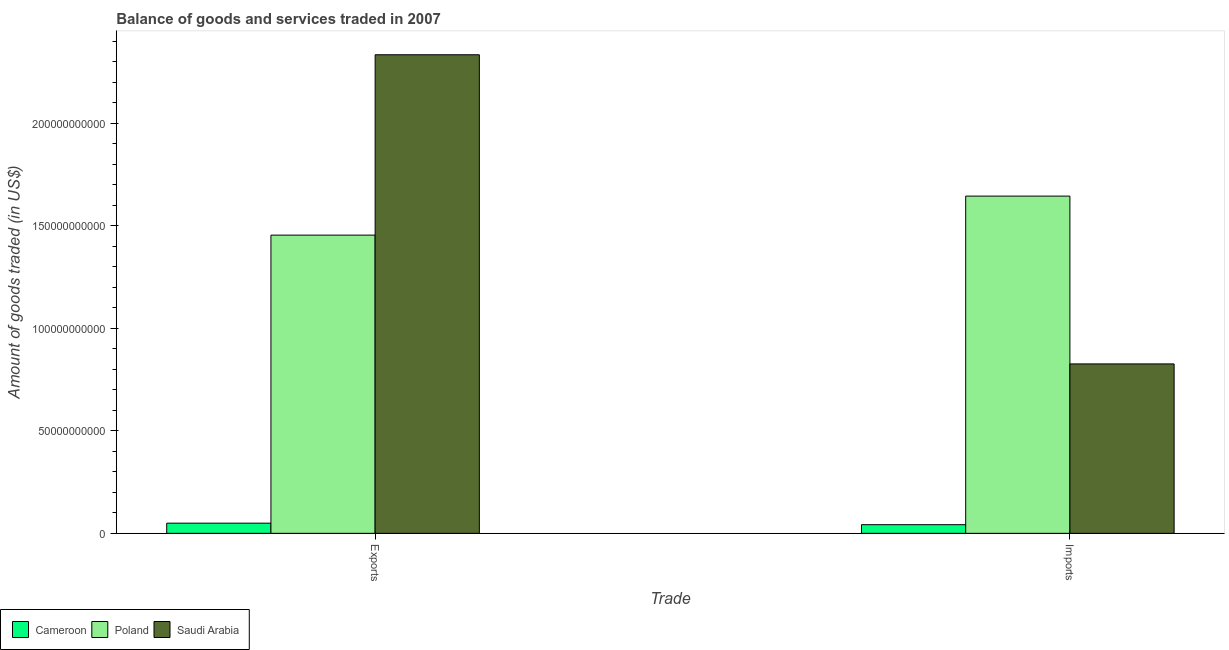How many different coloured bars are there?
Your response must be concise. 3. How many groups of bars are there?
Offer a very short reply. 2. Are the number of bars per tick equal to the number of legend labels?
Provide a short and direct response. Yes. How many bars are there on the 2nd tick from the left?
Give a very brief answer. 3. How many bars are there on the 2nd tick from the right?
Keep it short and to the point. 3. What is the label of the 1st group of bars from the left?
Provide a succinct answer. Exports. What is the amount of goods exported in Cameroon?
Make the answer very short. 4.96e+09. Across all countries, what is the maximum amount of goods imported?
Provide a short and direct response. 1.64e+11. Across all countries, what is the minimum amount of goods exported?
Keep it short and to the point. 4.96e+09. In which country was the amount of goods imported minimum?
Keep it short and to the point. Cameroon. What is the total amount of goods exported in the graph?
Offer a terse response. 3.84e+11. What is the difference between the amount of goods imported in Saudi Arabia and that in Poland?
Your response must be concise. -8.18e+1. What is the difference between the amount of goods exported in Poland and the amount of goods imported in Cameroon?
Make the answer very short. 1.41e+11. What is the average amount of goods imported per country?
Provide a succinct answer. 8.37e+1. What is the difference between the amount of goods imported and amount of goods exported in Poland?
Provide a succinct answer. 1.90e+1. In how many countries, is the amount of goods imported greater than 190000000000 US$?
Your answer should be compact. 0. What is the ratio of the amount of goods exported in Saudi Arabia to that in Cameroon?
Keep it short and to the point. 47.08. What does the 3rd bar from the left in Imports represents?
Keep it short and to the point. Saudi Arabia. What does the 1st bar from the right in Imports represents?
Offer a terse response. Saudi Arabia. What is the difference between two consecutive major ticks on the Y-axis?
Offer a very short reply. 5.00e+1. Are the values on the major ticks of Y-axis written in scientific E-notation?
Your response must be concise. No. Where does the legend appear in the graph?
Ensure brevity in your answer.  Bottom left. How are the legend labels stacked?
Give a very brief answer. Horizontal. What is the title of the graph?
Your answer should be very brief. Balance of goods and services traded in 2007. Does "Senegal" appear as one of the legend labels in the graph?
Offer a very short reply. No. What is the label or title of the X-axis?
Your response must be concise. Trade. What is the label or title of the Y-axis?
Make the answer very short. Amount of goods traded (in US$). What is the Amount of goods traded (in US$) of Cameroon in Exports?
Provide a succinct answer. 4.96e+09. What is the Amount of goods traded (in US$) in Poland in Exports?
Your answer should be compact. 1.45e+11. What is the Amount of goods traded (in US$) in Saudi Arabia in Exports?
Make the answer very short. 2.33e+11. What is the Amount of goods traded (in US$) in Cameroon in Imports?
Provide a succinct answer. 4.22e+09. What is the Amount of goods traded (in US$) of Poland in Imports?
Keep it short and to the point. 1.64e+11. What is the Amount of goods traded (in US$) of Saudi Arabia in Imports?
Keep it short and to the point. 8.26e+1. Across all Trade, what is the maximum Amount of goods traded (in US$) of Cameroon?
Give a very brief answer. 4.96e+09. Across all Trade, what is the maximum Amount of goods traded (in US$) in Poland?
Make the answer very short. 1.64e+11. Across all Trade, what is the maximum Amount of goods traded (in US$) in Saudi Arabia?
Offer a terse response. 2.33e+11. Across all Trade, what is the minimum Amount of goods traded (in US$) of Cameroon?
Ensure brevity in your answer.  4.22e+09. Across all Trade, what is the minimum Amount of goods traded (in US$) in Poland?
Offer a terse response. 1.45e+11. Across all Trade, what is the minimum Amount of goods traded (in US$) in Saudi Arabia?
Provide a succinct answer. 8.26e+1. What is the total Amount of goods traded (in US$) in Cameroon in the graph?
Keep it short and to the point. 9.18e+09. What is the total Amount of goods traded (in US$) of Poland in the graph?
Offer a terse response. 3.10e+11. What is the total Amount of goods traded (in US$) in Saudi Arabia in the graph?
Provide a succinct answer. 3.16e+11. What is the difference between the Amount of goods traded (in US$) of Cameroon in Exports and that in Imports?
Your response must be concise. 7.35e+08. What is the difference between the Amount of goods traded (in US$) of Poland in Exports and that in Imports?
Provide a succinct answer. -1.90e+1. What is the difference between the Amount of goods traded (in US$) in Saudi Arabia in Exports and that in Imports?
Make the answer very short. 1.51e+11. What is the difference between the Amount of goods traded (in US$) of Cameroon in Exports and the Amount of goods traded (in US$) of Poland in Imports?
Your answer should be very brief. -1.59e+11. What is the difference between the Amount of goods traded (in US$) of Cameroon in Exports and the Amount of goods traded (in US$) of Saudi Arabia in Imports?
Offer a very short reply. -7.76e+1. What is the difference between the Amount of goods traded (in US$) in Poland in Exports and the Amount of goods traded (in US$) in Saudi Arabia in Imports?
Your answer should be very brief. 6.28e+1. What is the average Amount of goods traded (in US$) of Cameroon per Trade?
Your answer should be very brief. 4.59e+09. What is the average Amount of goods traded (in US$) in Poland per Trade?
Your answer should be compact. 1.55e+11. What is the average Amount of goods traded (in US$) of Saudi Arabia per Trade?
Offer a very short reply. 1.58e+11. What is the difference between the Amount of goods traded (in US$) in Cameroon and Amount of goods traded (in US$) in Poland in Exports?
Ensure brevity in your answer.  -1.40e+11. What is the difference between the Amount of goods traded (in US$) in Cameroon and Amount of goods traded (in US$) in Saudi Arabia in Exports?
Your answer should be very brief. -2.28e+11. What is the difference between the Amount of goods traded (in US$) in Poland and Amount of goods traded (in US$) in Saudi Arabia in Exports?
Give a very brief answer. -8.79e+1. What is the difference between the Amount of goods traded (in US$) of Cameroon and Amount of goods traded (in US$) of Poland in Imports?
Offer a very short reply. -1.60e+11. What is the difference between the Amount of goods traded (in US$) in Cameroon and Amount of goods traded (in US$) in Saudi Arabia in Imports?
Your answer should be compact. -7.84e+1. What is the difference between the Amount of goods traded (in US$) of Poland and Amount of goods traded (in US$) of Saudi Arabia in Imports?
Your answer should be compact. 8.18e+1. What is the ratio of the Amount of goods traded (in US$) of Cameroon in Exports to that in Imports?
Provide a succinct answer. 1.17. What is the ratio of the Amount of goods traded (in US$) in Poland in Exports to that in Imports?
Provide a succinct answer. 0.88. What is the ratio of the Amount of goods traded (in US$) of Saudi Arabia in Exports to that in Imports?
Provide a succinct answer. 2.82. What is the difference between the highest and the second highest Amount of goods traded (in US$) of Cameroon?
Give a very brief answer. 7.35e+08. What is the difference between the highest and the second highest Amount of goods traded (in US$) of Poland?
Provide a short and direct response. 1.90e+1. What is the difference between the highest and the second highest Amount of goods traded (in US$) in Saudi Arabia?
Provide a short and direct response. 1.51e+11. What is the difference between the highest and the lowest Amount of goods traded (in US$) of Cameroon?
Ensure brevity in your answer.  7.35e+08. What is the difference between the highest and the lowest Amount of goods traded (in US$) of Poland?
Your answer should be compact. 1.90e+1. What is the difference between the highest and the lowest Amount of goods traded (in US$) of Saudi Arabia?
Your response must be concise. 1.51e+11. 